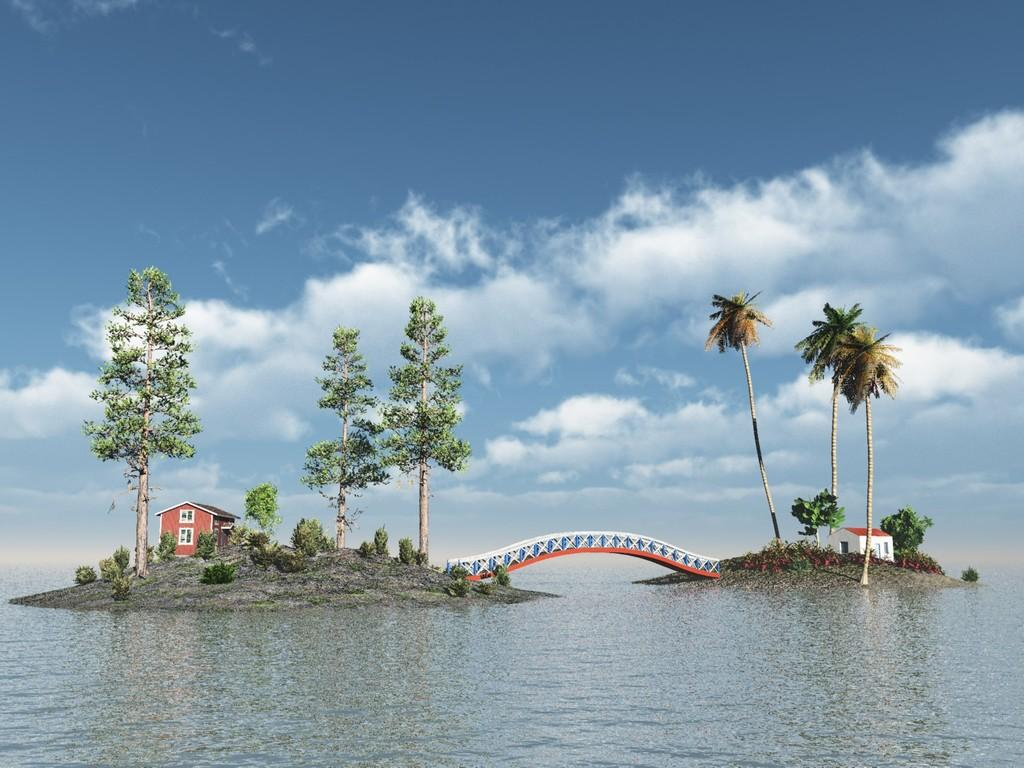What is the primary element visible in the image? There is water in the image. What type of structures can be seen in the image? There are buildings in the image. What type of man-made structure is present in the water? There is a walkway bridge in the image. What type of vegetation is present in the image? Trees and bushes are visible in the image. What is visible in the background of the image? The sky is visible in the image, and clouds are present in the sky. Can you tell me what type of owl is sitting on the walkway bridge in the image? There is no owl present on the walkway bridge in the image. What topic are the buildings discussing in the image? Buildings do not have the ability to discuss topics, as they are inanimate structures. 